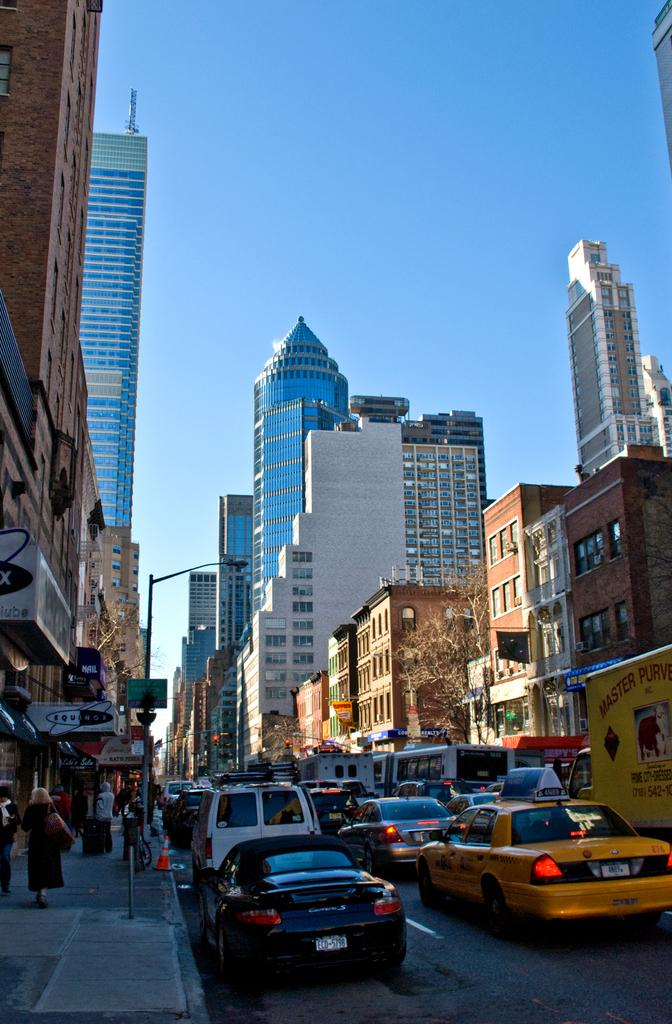<image>
Provide a brief description of the given image. a license plate on a black car that says ECD 